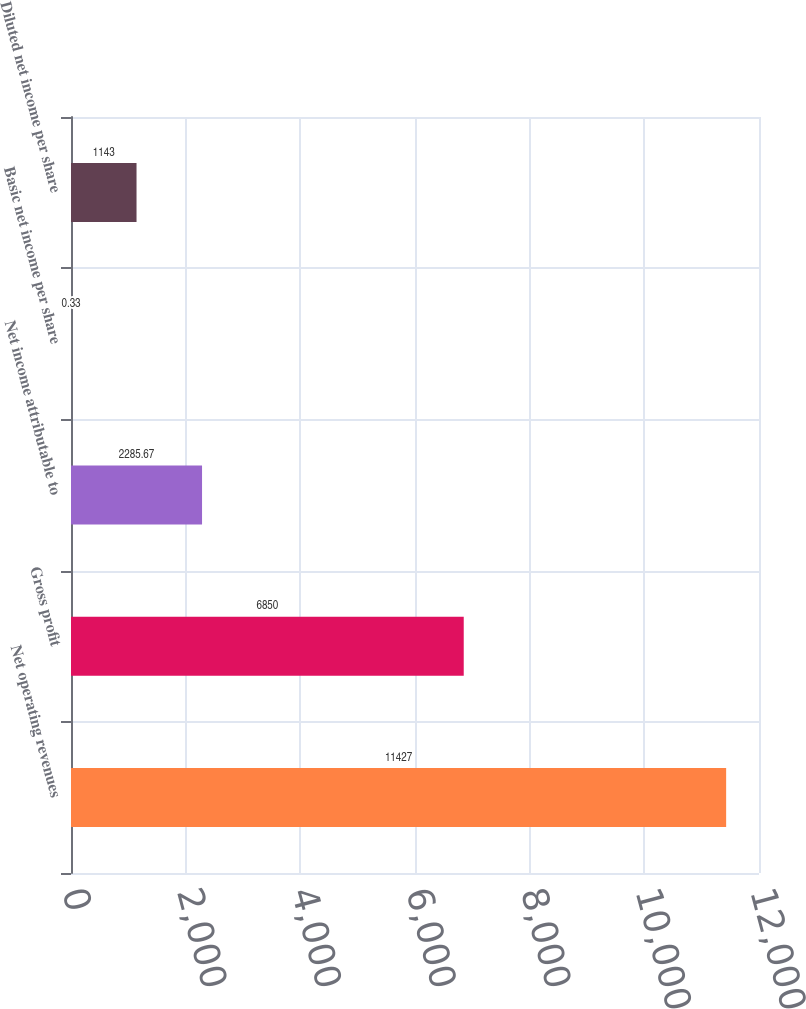Convert chart to OTSL. <chart><loc_0><loc_0><loc_500><loc_500><bar_chart><fcel>Net operating revenues<fcel>Gross profit<fcel>Net income attributable to<fcel>Basic net income per share<fcel>Diluted net income per share<nl><fcel>11427<fcel>6850<fcel>2285.67<fcel>0.33<fcel>1143<nl></chart> 